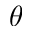Convert formula to latex. <formula><loc_0><loc_0><loc_500><loc_500>\theta</formula> 